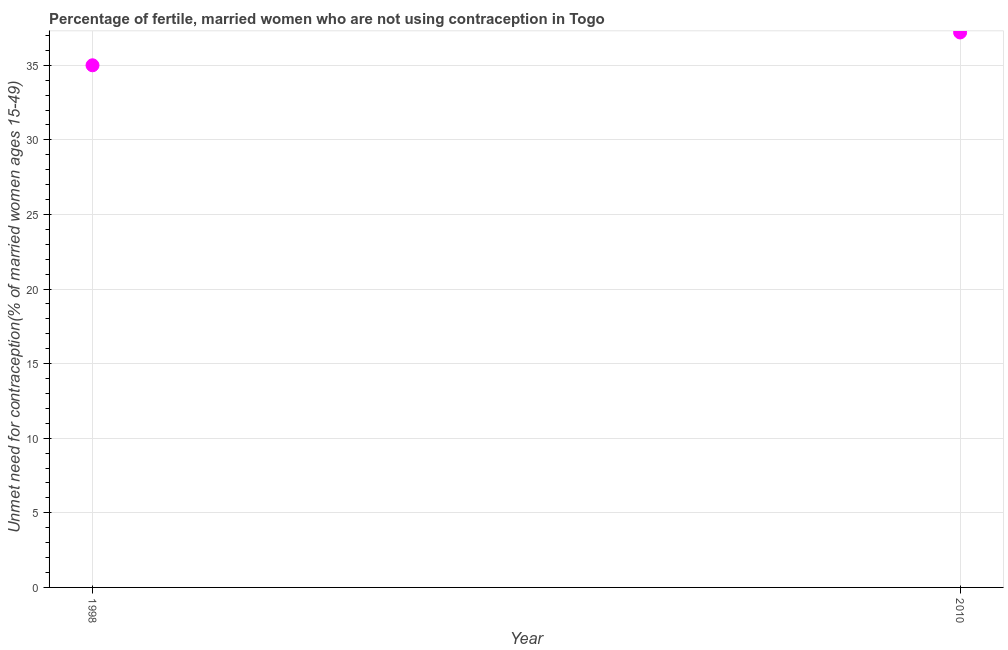What is the number of married women who are not using contraception in 2010?
Keep it short and to the point. 37.2. Across all years, what is the maximum number of married women who are not using contraception?
Provide a short and direct response. 37.2. In which year was the number of married women who are not using contraception maximum?
Ensure brevity in your answer.  2010. What is the sum of the number of married women who are not using contraception?
Keep it short and to the point. 72.2. What is the difference between the number of married women who are not using contraception in 1998 and 2010?
Provide a short and direct response. -2.2. What is the average number of married women who are not using contraception per year?
Keep it short and to the point. 36.1. What is the median number of married women who are not using contraception?
Give a very brief answer. 36.1. Do a majority of the years between 1998 and 2010 (inclusive) have number of married women who are not using contraception greater than 22 %?
Your answer should be compact. Yes. What is the ratio of the number of married women who are not using contraception in 1998 to that in 2010?
Your response must be concise. 0.94. Does the number of married women who are not using contraception monotonically increase over the years?
Provide a short and direct response. Yes. How many dotlines are there?
Your response must be concise. 1. How many years are there in the graph?
Your answer should be compact. 2. Are the values on the major ticks of Y-axis written in scientific E-notation?
Give a very brief answer. No. What is the title of the graph?
Your answer should be compact. Percentage of fertile, married women who are not using contraception in Togo. What is the label or title of the Y-axis?
Make the answer very short.  Unmet need for contraception(% of married women ages 15-49). What is the  Unmet need for contraception(% of married women ages 15-49) in 1998?
Make the answer very short. 35. What is the  Unmet need for contraception(% of married women ages 15-49) in 2010?
Offer a very short reply. 37.2. What is the ratio of the  Unmet need for contraception(% of married women ages 15-49) in 1998 to that in 2010?
Ensure brevity in your answer.  0.94. 